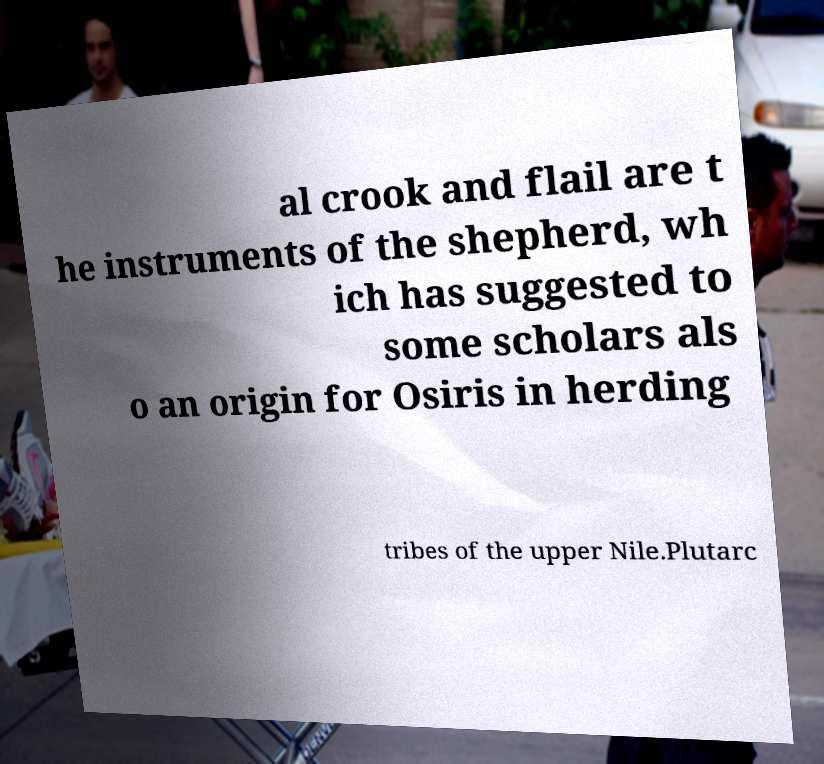What messages or text are displayed in this image? I need them in a readable, typed format. al crook and flail are t he instruments of the shepherd, wh ich has suggested to some scholars als o an origin for Osiris in herding tribes of the upper Nile.Plutarc 